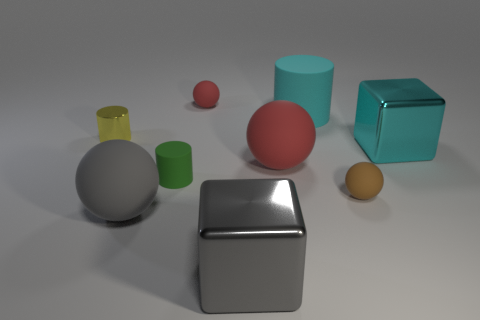There is a large cube that is to the right of the gray shiny thing; is there a big red matte sphere that is right of it?
Ensure brevity in your answer.  No. Is there a brown metallic cylinder that has the same size as the cyan cube?
Provide a succinct answer. No. Is the color of the large metal thing in front of the big red sphere the same as the small shiny cylinder?
Make the answer very short. No. What is the size of the brown matte sphere?
Offer a very short reply. Small. There is a red object that is to the right of the tiny matte object that is behind the yellow shiny thing; what is its size?
Offer a very short reply. Large. What number of shiny cylinders have the same color as the large rubber cylinder?
Make the answer very short. 0. How many things are there?
Keep it short and to the point. 9. How many tiny blue cubes have the same material as the big cyan cube?
Keep it short and to the point. 0. The green matte thing that is the same shape as the yellow metal object is what size?
Ensure brevity in your answer.  Small. What is the gray block made of?
Offer a very short reply. Metal. 